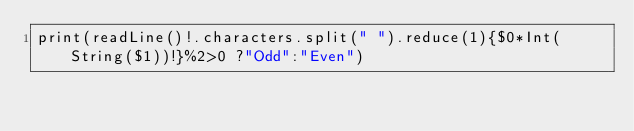Convert code to text. <code><loc_0><loc_0><loc_500><loc_500><_Swift_>print(readLine()!.characters.split(" ").reduce(1){$0*Int(String($1))!}%2>0 ?"Odd":"Even")</code> 